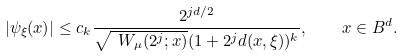<formula> <loc_0><loc_0><loc_500><loc_500>| \psi _ { \xi } ( x ) | \leq c _ { k } \frac { 2 ^ { j d / 2 } } { \sqrt { \ W _ { \mu } ( 2 ^ { j } ; x ) } ( 1 + 2 ^ { j } d ( x , \xi ) ) ^ { k } } , \quad x \in B ^ { d } .</formula> 